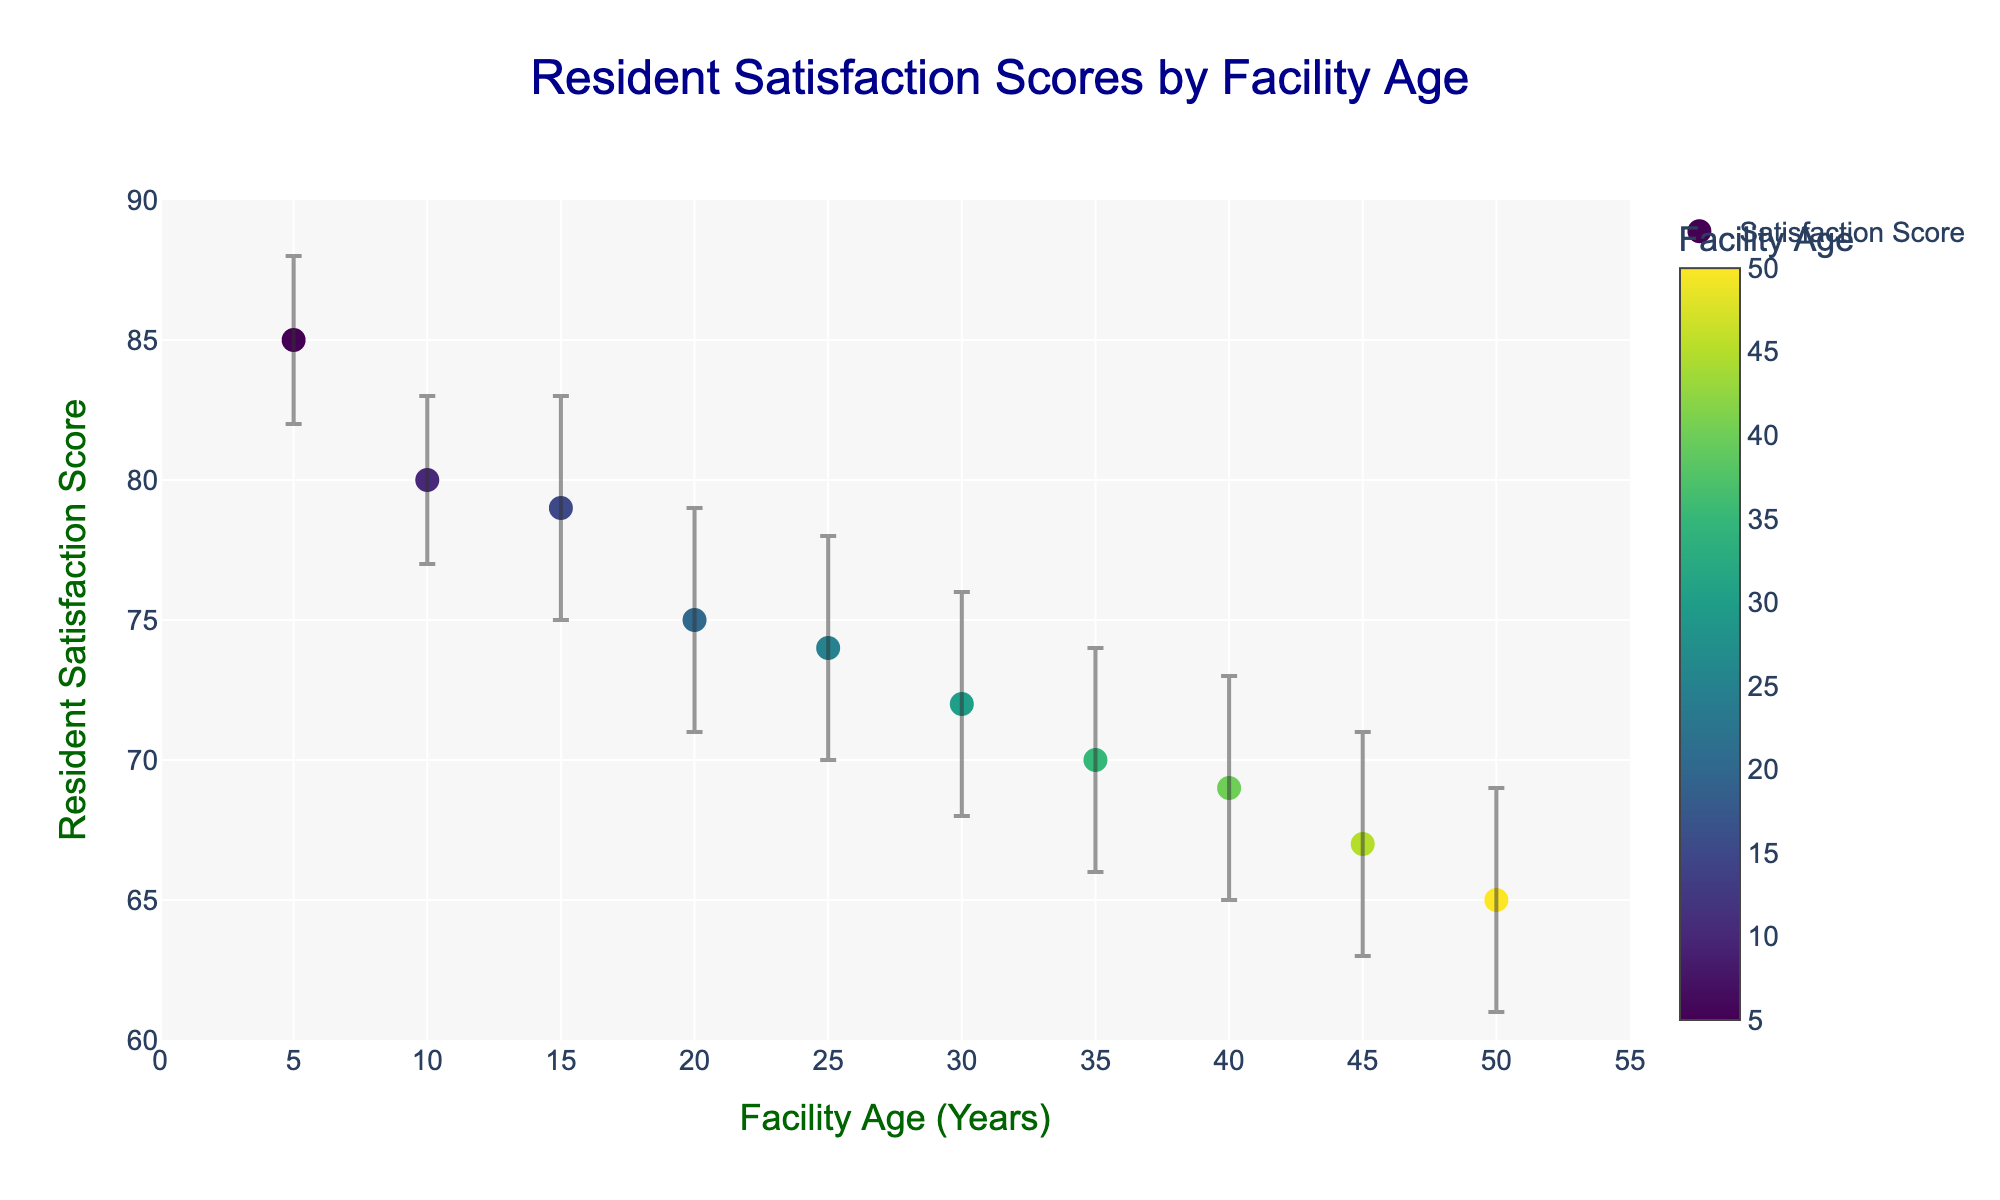What's the title of the scatter plot? The title of the figure is usually displayed prominently at the top. In this case, it is "Resident Satisfaction Scores by Facility Age".
Answer: Resident Satisfaction Scores by Facility Age What axes titles are used in the scatter plot? The x-axis and y-axis titles are displayed below and to the left of the axes respectively. The x-axis is titled "Facility Age (Years)" and the y-axis is titled "Resident Satisfaction Score".
Answer: Facility Age (Years), Resident Satisfaction Score How many data points are plotted in the scatter plot? Count the number of dots (data points) in the scatter plot. Each data point corresponds to a facility. There are data points for 10 facilities.
Answer: 10 Which facility has the highest resident satisfaction score? Look for the data point with the highest y-value. Hovering over the points may help identify the facility's name. The highest score is 85 for Green Meadows Nursing Home.
Answer: Green Meadows Nursing Home What is the approximate trend between facility age and resident satisfaction score? Observe the overall direction of the data points. They seem to show a general decline in satisfaction scores as the facility age increases.
Answer: Declining trend What is the resident satisfaction score for the oldest facility, and what is its age? Identify the data point with the highest x-value (oldest facility). This data point corresponds to Harmony Hills Senior Care with an age of 50 years and a satisfaction score of 65.
Answer: 65, 50 years What is the age difference between the facility with the highest score and the facility with the lowest score? The highest score (85) is by Green Meadows Nursing Home (5 years) and the lowest score (65) by Harmony Hills Senior Care (50 years). The difference in age is 50 - 5 = 45 years.
Answer: 45 years Which facility has the widest confidence interval in resident satisfaction score? The width of the confidence interval can be found by checking the difference between the upper and lower bounds of the intervals. RiverView Rehabilitation Center has the widest interval (79 - 71 = 8).
Answer: RiverView Rehabilitation Center Is there any facility with a resident satisfaction score higher than its upper confidence interval? Compare all resident satisfaction scores with their respective upper confidence intervals. All scores are within their confidence intervals, so the answer is no.
Answer: No Between Pine Hills Nursing Facility and Maple Leaf Elder Care, which has a higher resident satisfaction score and by how much? Check the y-values (scores) for Pine Hills (80) and Maple Leaf (74). The difference in scores is 80 - 74 = 6. Pine Hills has a higher score by 6 points.
Answer: Pine Hills, 6 points 